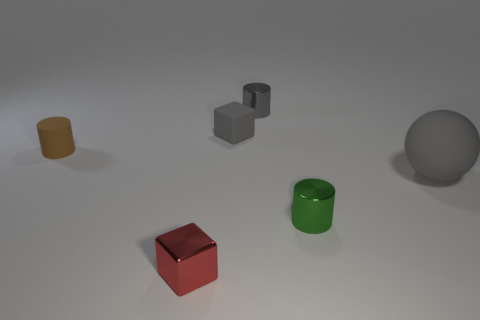How is the lighting affecting the appearance of the objects? The lighting in the image is casting soft shadows on the ground beneath the objects and is highlighting their top surfaces, which enhances their three-dimensionality and differentiates their shapes and materials. 